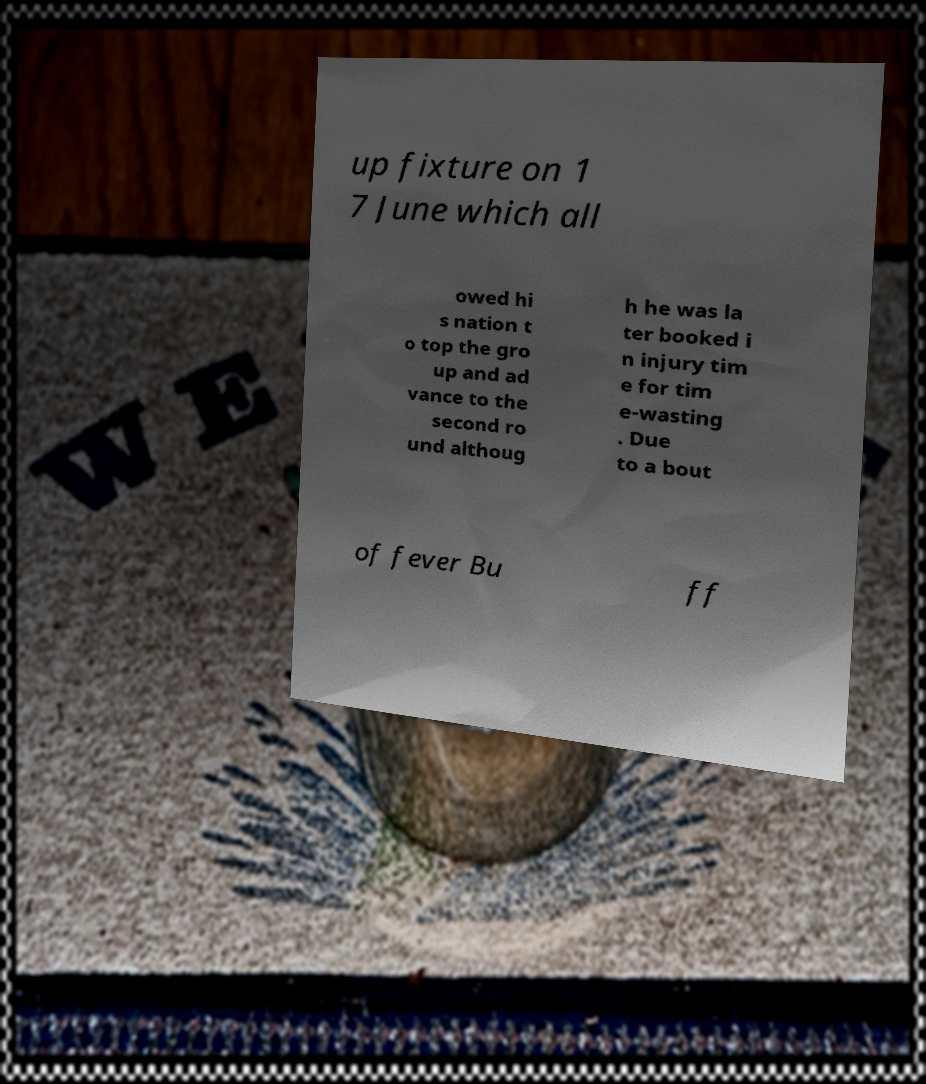Can you read and provide the text displayed in the image?This photo seems to have some interesting text. Can you extract and type it out for me? up fixture on 1 7 June which all owed hi s nation t o top the gro up and ad vance to the second ro und althoug h he was la ter booked i n injury tim e for tim e-wasting . Due to a bout of fever Bu ff 